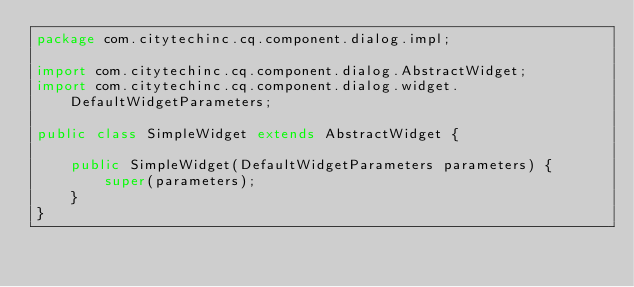Convert code to text. <code><loc_0><loc_0><loc_500><loc_500><_Java_>package com.citytechinc.cq.component.dialog.impl;

import com.citytechinc.cq.component.dialog.AbstractWidget;
import com.citytechinc.cq.component.dialog.widget.DefaultWidgetParameters;

public class SimpleWidget extends AbstractWidget {

    public SimpleWidget(DefaultWidgetParameters parameters) {
        super(parameters);
    }
}
</code> 